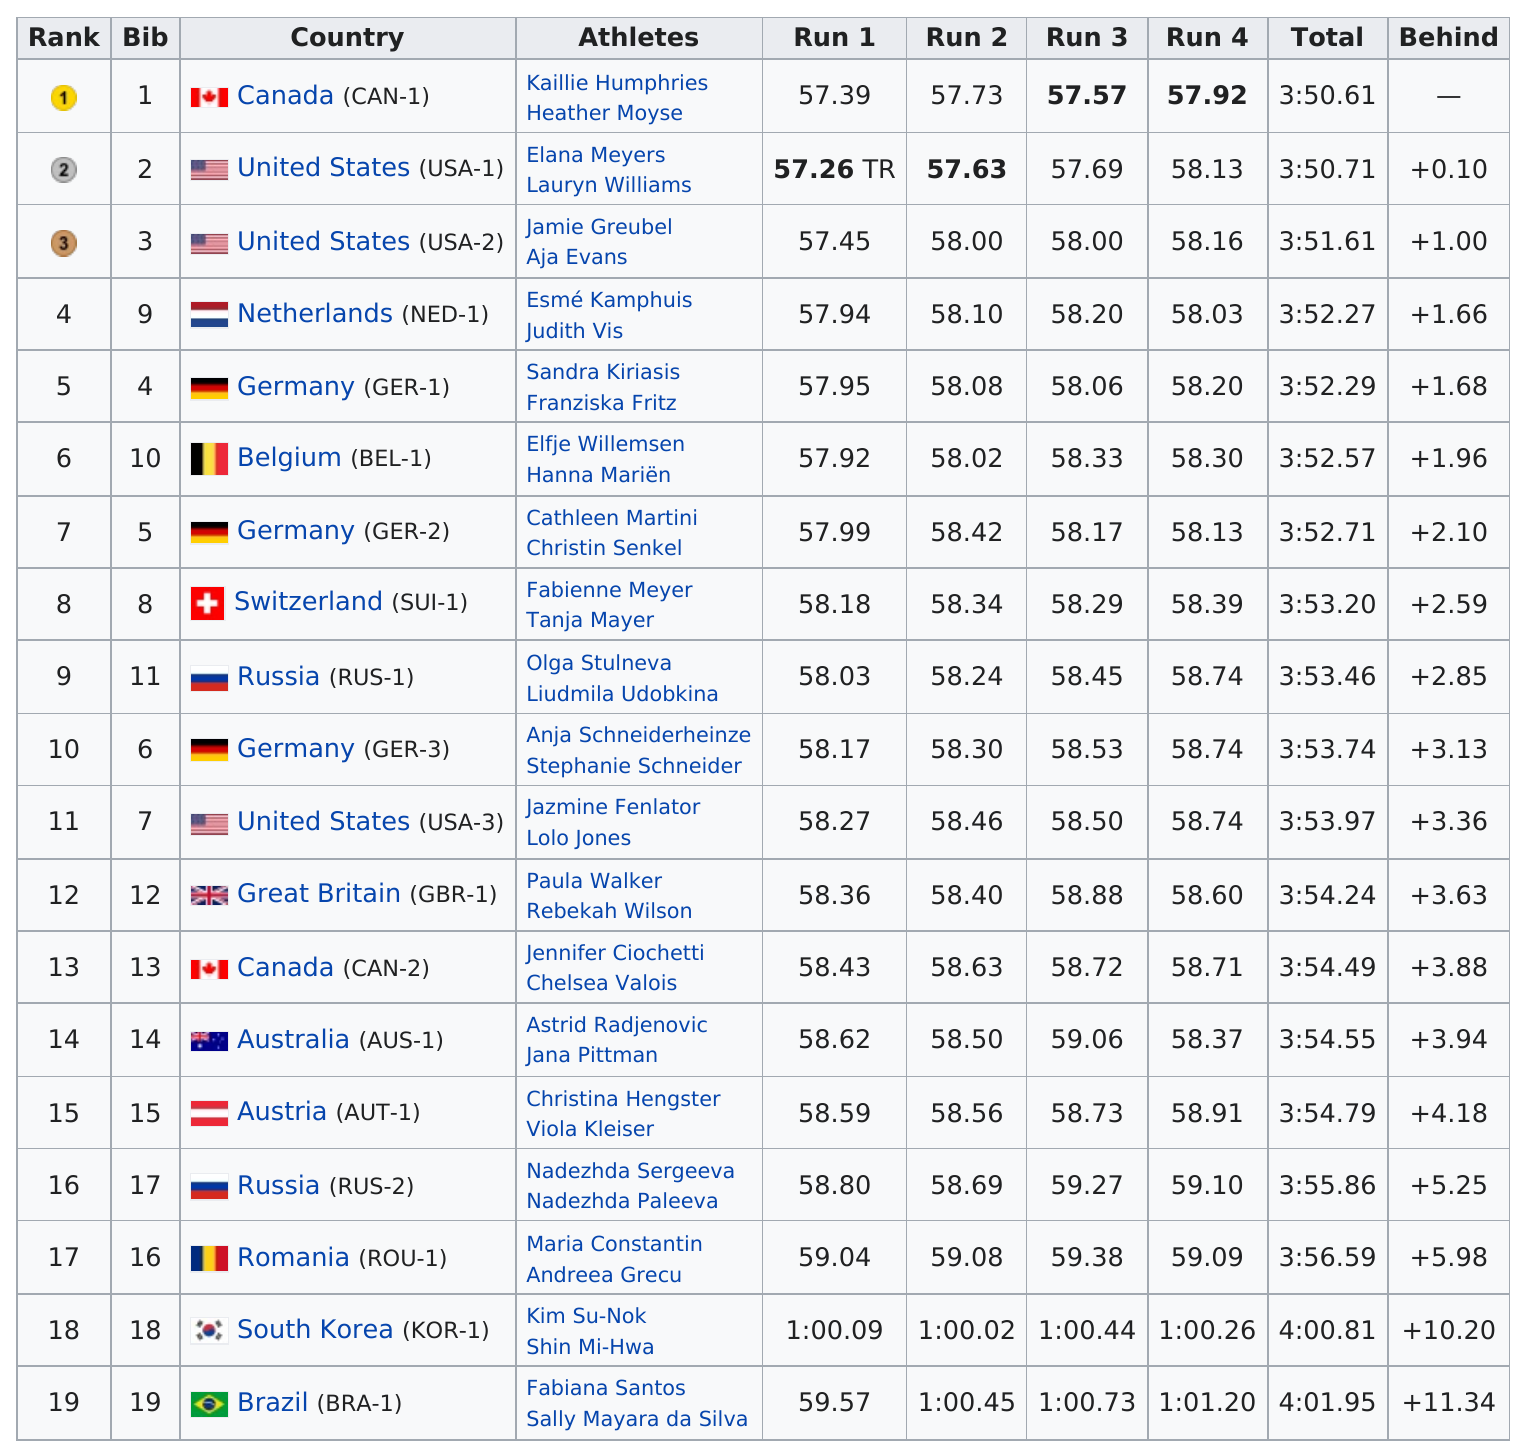Mention a couple of crucial points in this snapshot. The United States was one of the countries that had three teams competing. The team that was faster was Germany, as they were declared the winner against Russia. Canada was the top scorer in that country. USA-1 or USA-2 was faster. USA-1.. Of the teams that completed the task, how many had a total time that was above 4 minutes? 